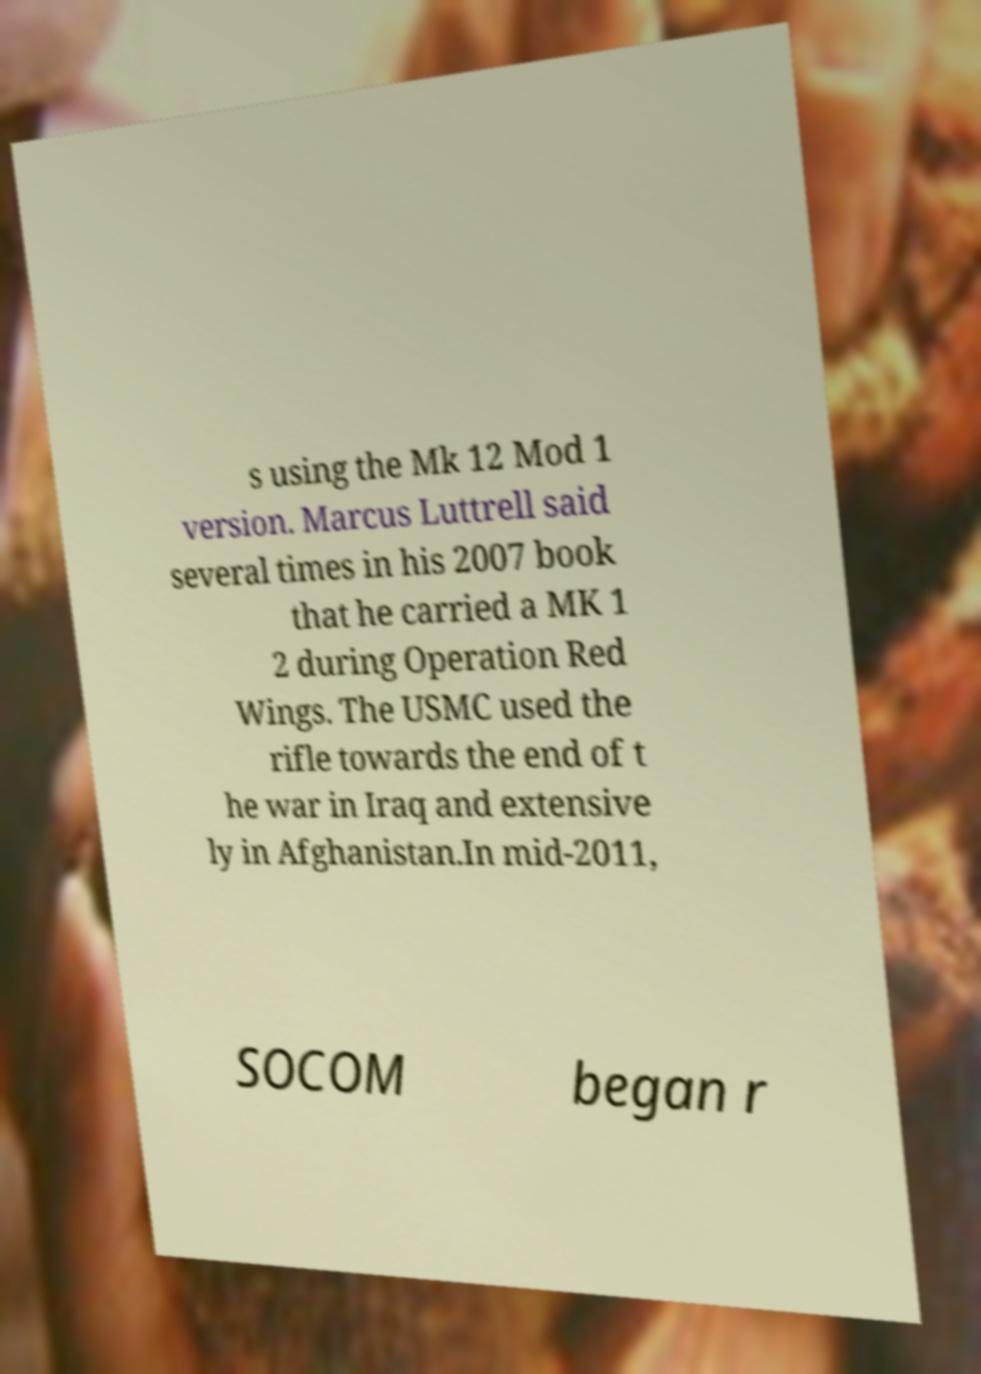Can you read and provide the text displayed in the image?This photo seems to have some interesting text. Can you extract and type it out for me? s using the Mk 12 Mod 1 version. Marcus Luttrell said several times in his 2007 book that he carried a MK 1 2 during Operation Red Wings. The USMC used the rifle towards the end of t he war in Iraq and extensive ly in Afghanistan.In mid-2011, SOCOM began r 